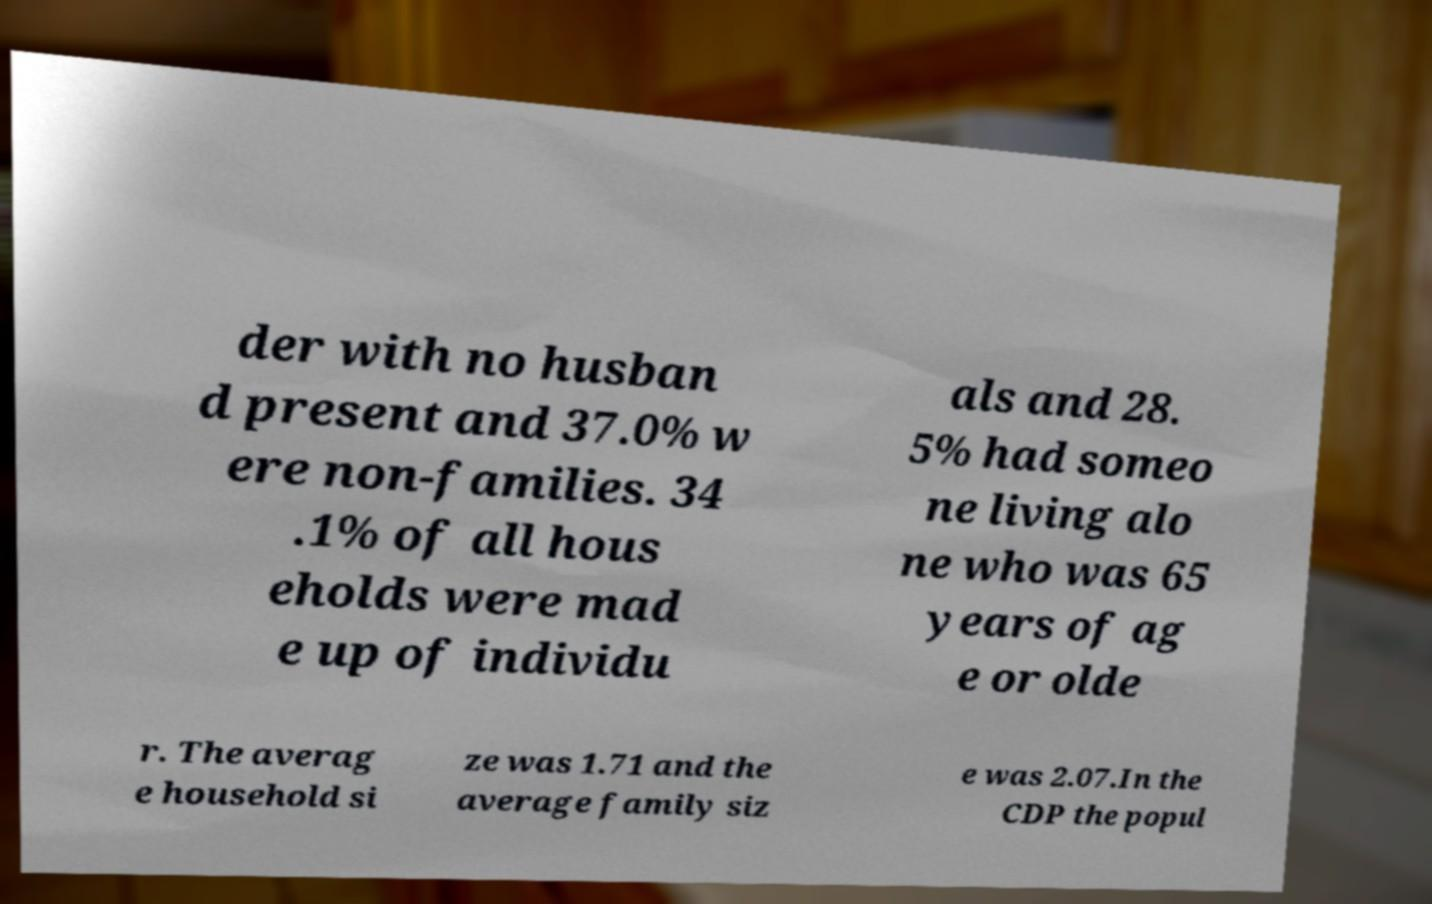There's text embedded in this image that I need extracted. Can you transcribe it verbatim? der with no husban d present and 37.0% w ere non-families. 34 .1% of all hous eholds were mad e up of individu als and 28. 5% had someo ne living alo ne who was 65 years of ag e or olde r. The averag e household si ze was 1.71 and the average family siz e was 2.07.In the CDP the popul 